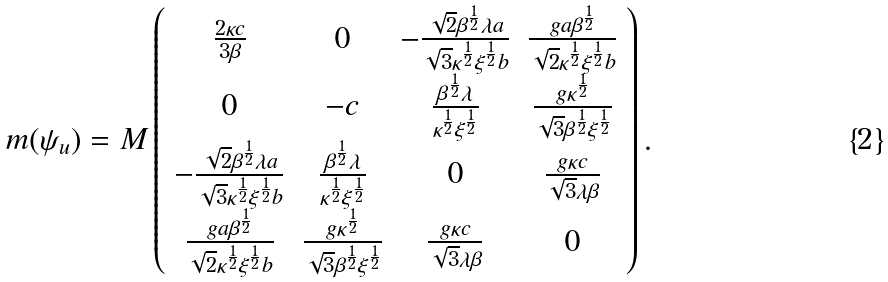Convert formula to latex. <formula><loc_0><loc_0><loc_500><loc_500>m ( \psi _ { u } ) = M \left ( \begin{array} { c c c c } \frac { 2 \kappa c } { 3 \beta } & 0 & - \frac { \sqrt { 2 } \beta ^ { \frac { 1 } { 2 } } \lambda a } { \sqrt { 3 } \kappa ^ { \frac { 1 } { 2 } } \xi ^ { \frac { 1 } { 2 } } b } & \frac { g a \beta ^ { \frac { 1 } { 2 } } } { \sqrt { 2 } \kappa ^ { \frac { 1 } { 2 } } \xi ^ { \frac { 1 } { 2 } } b } \\ 0 & - c & \frac { \beta ^ { \frac { 1 } { 2 } } \lambda } { \kappa ^ { \frac { 1 } { 2 } } \xi ^ { \frac { 1 } { 2 } } } & \frac { g \kappa ^ { \frac { 1 } { 2 } } } { \sqrt { 3 } \beta ^ { \frac { 1 } { 2 } } \xi ^ { \frac { 1 } { 2 } } } \\ - \frac { \sqrt { 2 } \beta ^ { \frac { 1 } { 2 } } \lambda a } { \sqrt { 3 } \kappa ^ { \frac { 1 } { 2 } } \xi ^ { \frac { 1 } { 2 } } b } & \frac { \beta ^ { \frac { 1 } { 2 } } \lambda } { \kappa ^ { \frac { 1 } { 2 } } \xi ^ { \frac { 1 } { 2 } } } & 0 & \frac { g \kappa c } { \sqrt { 3 } \lambda \beta } \\ \frac { g a \beta ^ { \frac { 1 } { 2 } } } { \sqrt { 2 } \kappa ^ { \frac { 1 } { 2 } } \xi ^ { \frac { 1 } { 2 } } b } & \frac { g \kappa ^ { \frac { 1 } { 2 } } } { \sqrt { 3 } \beta ^ { \frac { 1 } { 2 } } \xi ^ { \frac { 1 } { 2 } } } & \frac { g \kappa c } { \sqrt { 3 } \lambda \beta } & 0 \end{array} \right ) .</formula> 